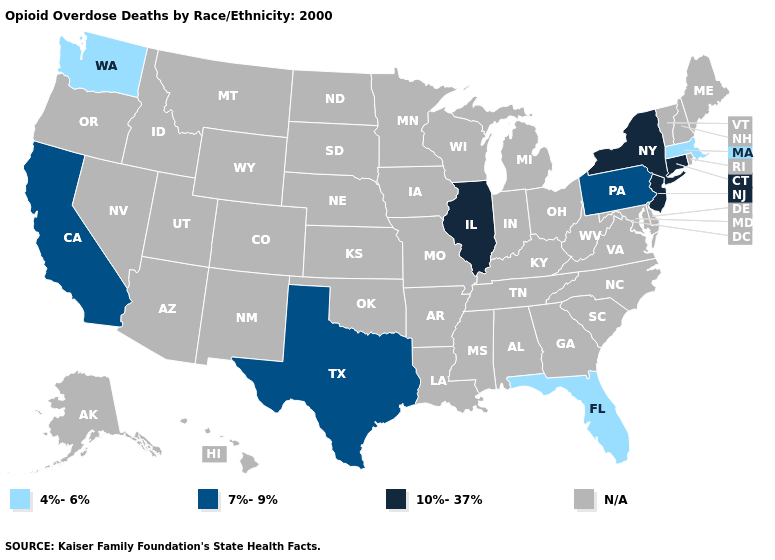Does the map have missing data?
Quick response, please. Yes. What is the value of North Dakota?
Give a very brief answer. N/A. Does the map have missing data?
Quick response, please. Yes. Is the legend a continuous bar?
Keep it brief. No. Which states have the lowest value in the USA?
Answer briefly. Florida, Massachusetts, Washington. Name the states that have a value in the range N/A?
Write a very short answer. Alabama, Alaska, Arizona, Arkansas, Colorado, Delaware, Georgia, Hawaii, Idaho, Indiana, Iowa, Kansas, Kentucky, Louisiana, Maine, Maryland, Michigan, Minnesota, Mississippi, Missouri, Montana, Nebraska, Nevada, New Hampshire, New Mexico, North Carolina, North Dakota, Ohio, Oklahoma, Oregon, Rhode Island, South Carolina, South Dakota, Tennessee, Utah, Vermont, Virginia, West Virginia, Wisconsin, Wyoming. Name the states that have a value in the range N/A?
Answer briefly. Alabama, Alaska, Arizona, Arkansas, Colorado, Delaware, Georgia, Hawaii, Idaho, Indiana, Iowa, Kansas, Kentucky, Louisiana, Maine, Maryland, Michigan, Minnesota, Mississippi, Missouri, Montana, Nebraska, Nevada, New Hampshire, New Mexico, North Carolina, North Dakota, Ohio, Oklahoma, Oregon, Rhode Island, South Carolina, South Dakota, Tennessee, Utah, Vermont, Virginia, West Virginia, Wisconsin, Wyoming. Name the states that have a value in the range N/A?
Short answer required. Alabama, Alaska, Arizona, Arkansas, Colorado, Delaware, Georgia, Hawaii, Idaho, Indiana, Iowa, Kansas, Kentucky, Louisiana, Maine, Maryland, Michigan, Minnesota, Mississippi, Missouri, Montana, Nebraska, Nevada, New Hampshire, New Mexico, North Carolina, North Dakota, Ohio, Oklahoma, Oregon, Rhode Island, South Carolina, South Dakota, Tennessee, Utah, Vermont, Virginia, West Virginia, Wisconsin, Wyoming. What is the value of Texas?
Give a very brief answer. 7%-9%. Name the states that have a value in the range 4%-6%?
Answer briefly. Florida, Massachusetts, Washington. Is the legend a continuous bar?
Quick response, please. No. What is the value of Arizona?
Write a very short answer. N/A. 